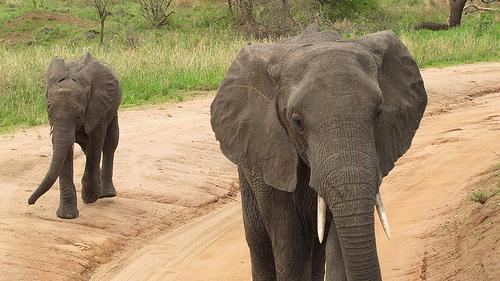How many people are there?
Give a very brief answer. 0. How many animals are there?
Give a very brief answer. 2. How many elephants are visible?
Give a very brief answer. 2. How many elephants are there?
Give a very brief answer. 2. How many elephants have tusks?
Give a very brief answer. 1. How many tusks does the foreground elephant have?
Give a very brief answer. 2. 